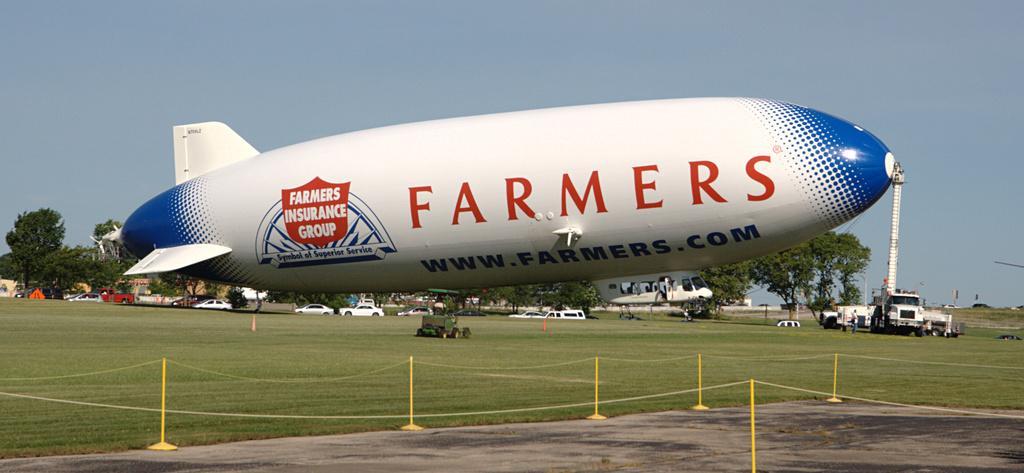How would you summarize this image in a sentence or two? In this image I can see a rigid ship , and there are some trees ,vehicles and small yellow color stand , rope attached to the stand visible on ground ,at the top there is the sky. 